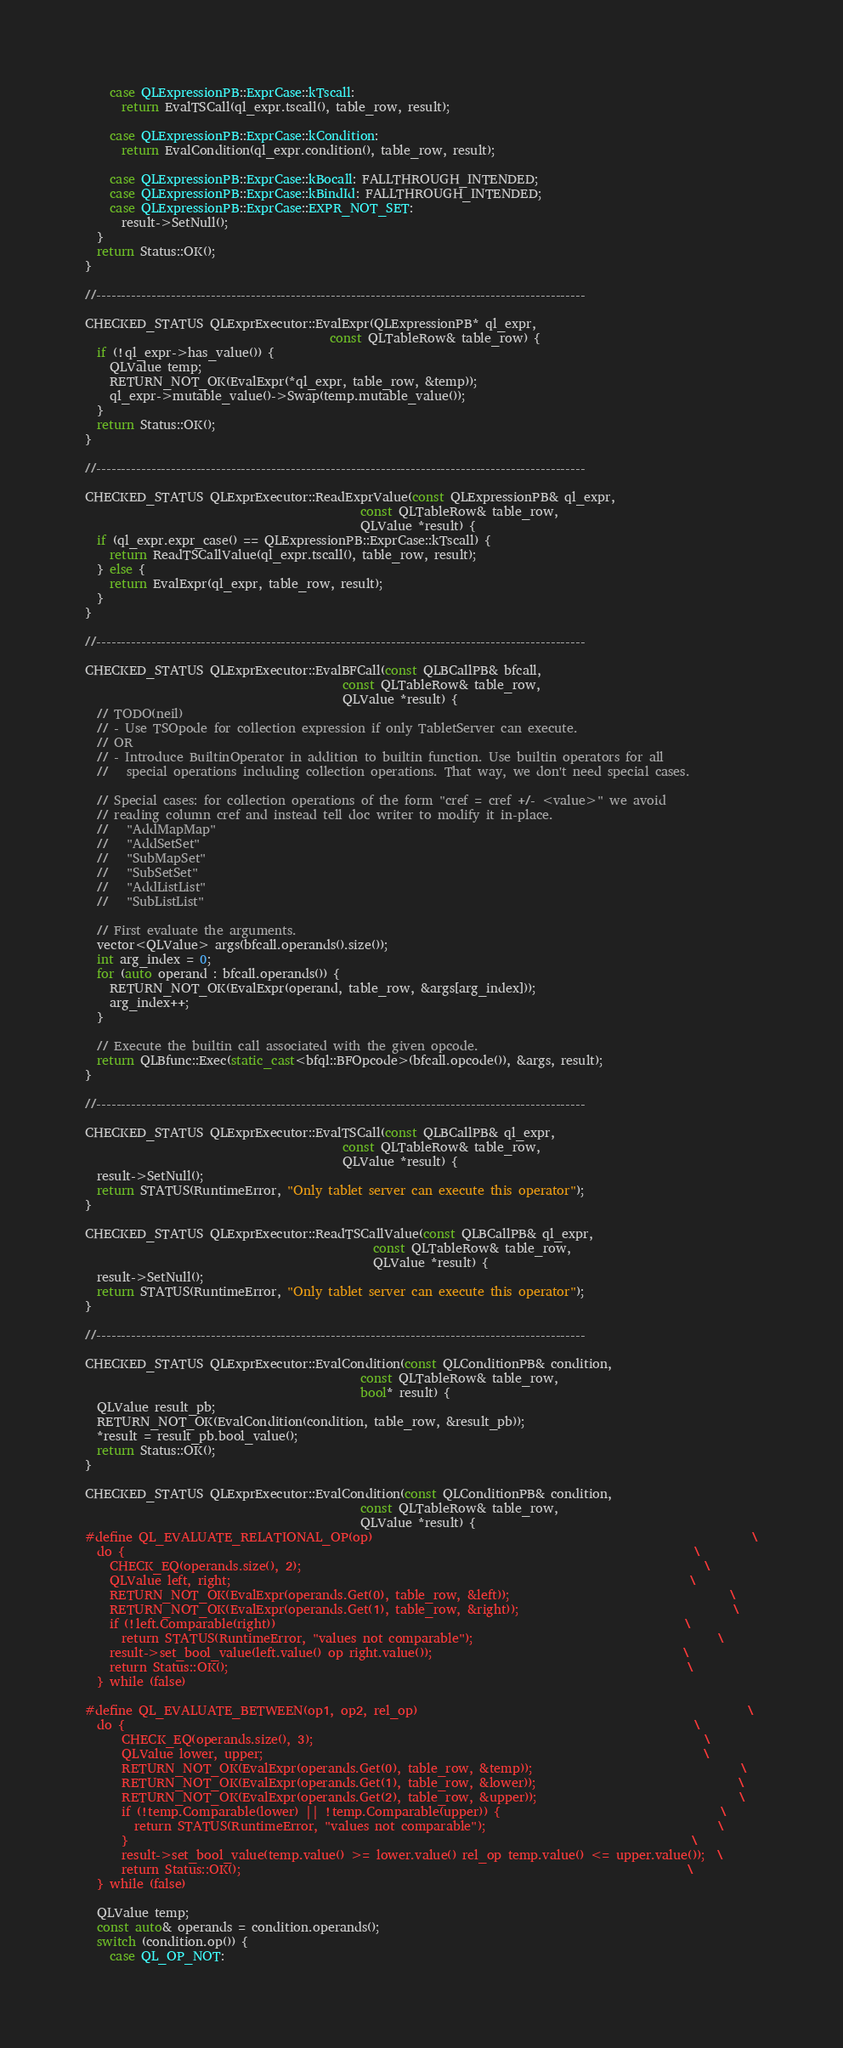<code> <loc_0><loc_0><loc_500><loc_500><_C++_>    case QLExpressionPB::ExprCase::kTscall:
      return EvalTSCall(ql_expr.tscall(), table_row, result);

    case QLExpressionPB::ExprCase::kCondition:
      return EvalCondition(ql_expr.condition(), table_row, result);

    case QLExpressionPB::ExprCase::kBocall: FALLTHROUGH_INTENDED;
    case QLExpressionPB::ExprCase::kBindId: FALLTHROUGH_INTENDED;
    case QLExpressionPB::ExprCase::EXPR_NOT_SET:
      result->SetNull();
  }
  return Status::OK();
}

//--------------------------------------------------------------------------------------------------

CHECKED_STATUS QLExprExecutor::EvalExpr(QLExpressionPB* ql_expr,
                                        const QLTableRow& table_row) {
  if (!ql_expr->has_value()) {
    QLValue temp;
    RETURN_NOT_OK(EvalExpr(*ql_expr, table_row, &temp));
    ql_expr->mutable_value()->Swap(temp.mutable_value());
  }
  return Status::OK();
}

//--------------------------------------------------------------------------------------------------

CHECKED_STATUS QLExprExecutor::ReadExprValue(const QLExpressionPB& ql_expr,
                                             const QLTableRow& table_row,
                                             QLValue *result) {
  if (ql_expr.expr_case() == QLExpressionPB::ExprCase::kTscall) {
    return ReadTSCallValue(ql_expr.tscall(), table_row, result);
  } else {
    return EvalExpr(ql_expr, table_row, result);
  }
}

//--------------------------------------------------------------------------------------------------

CHECKED_STATUS QLExprExecutor::EvalBFCall(const QLBCallPB& bfcall,
                                          const QLTableRow& table_row,
                                          QLValue *result) {
  // TODO(neil)
  // - Use TSOpode for collection expression if only TabletServer can execute.
  // OR
  // - Introduce BuiltinOperator in addition to builtin function. Use builtin operators for all
  //   special operations including collection operations. That way, we don't need special cases.

  // Special cases: for collection operations of the form "cref = cref +/- <value>" we avoid
  // reading column cref and instead tell doc writer to modify it in-place.
  //   "AddMapMap"
  //   "AddSetSet"
  //   "SubMapSet"
  //   "SubSetSet"
  //   "AddListList"
  //   "SubListList"

  // First evaluate the arguments.
  vector<QLValue> args(bfcall.operands().size());
  int arg_index = 0;
  for (auto operand : bfcall.operands()) {
    RETURN_NOT_OK(EvalExpr(operand, table_row, &args[arg_index]));
    arg_index++;
  }

  // Execute the builtin call associated with the given opcode.
  return QLBfunc::Exec(static_cast<bfql::BFOpcode>(bfcall.opcode()), &args, result);
}

//--------------------------------------------------------------------------------------------------

CHECKED_STATUS QLExprExecutor::EvalTSCall(const QLBCallPB& ql_expr,
                                          const QLTableRow& table_row,
                                          QLValue *result) {
  result->SetNull();
  return STATUS(RuntimeError, "Only tablet server can execute this operator");
}

CHECKED_STATUS QLExprExecutor::ReadTSCallValue(const QLBCallPB& ql_expr,
                                               const QLTableRow& table_row,
                                               QLValue *result) {
  result->SetNull();
  return STATUS(RuntimeError, "Only tablet server can execute this operator");
}

//--------------------------------------------------------------------------------------------------

CHECKED_STATUS QLExprExecutor::EvalCondition(const QLConditionPB& condition,
                                             const QLTableRow& table_row,
                                             bool* result) {
  QLValue result_pb;
  RETURN_NOT_OK(EvalCondition(condition, table_row, &result_pb));
  *result = result_pb.bool_value();
  return Status::OK();
}

CHECKED_STATUS QLExprExecutor::EvalCondition(const QLConditionPB& condition,
                                             const QLTableRow& table_row,
                                             QLValue *result) {
#define QL_EVALUATE_RELATIONAL_OP(op)                                                              \
  do {                                                                                             \
    CHECK_EQ(operands.size(), 2);                                                                  \
    QLValue left, right;                                                                           \
    RETURN_NOT_OK(EvalExpr(operands.Get(0), table_row, &left));                                    \
    RETURN_NOT_OK(EvalExpr(operands.Get(1), table_row, &right));                                   \
    if (!left.Comparable(right))                                                                   \
      return STATUS(RuntimeError, "values not comparable");                                        \
    result->set_bool_value(left.value() op right.value());                                         \
    return Status::OK();                                                                           \
  } while (false)

#define QL_EVALUATE_BETWEEN(op1, op2, rel_op)                                                      \
  do {                                                                                             \
      CHECK_EQ(operands.size(), 3);                                                                \
      QLValue lower, upper;                                                                        \
      RETURN_NOT_OK(EvalExpr(operands.Get(0), table_row, &temp));                                  \
      RETURN_NOT_OK(EvalExpr(operands.Get(1), table_row, &lower));                                 \
      RETURN_NOT_OK(EvalExpr(operands.Get(2), table_row, &upper));                                 \
      if (!temp.Comparable(lower) || !temp.Comparable(upper)) {                                    \
        return STATUS(RuntimeError, "values not comparable");                                      \
      }                                                                                            \
      result->set_bool_value(temp.value() >= lower.value() rel_op temp.value() <= upper.value());  \
      return Status::OK();                                                                         \
  } while (false)

  QLValue temp;
  const auto& operands = condition.operands();
  switch (condition.op()) {
    case QL_OP_NOT:</code> 